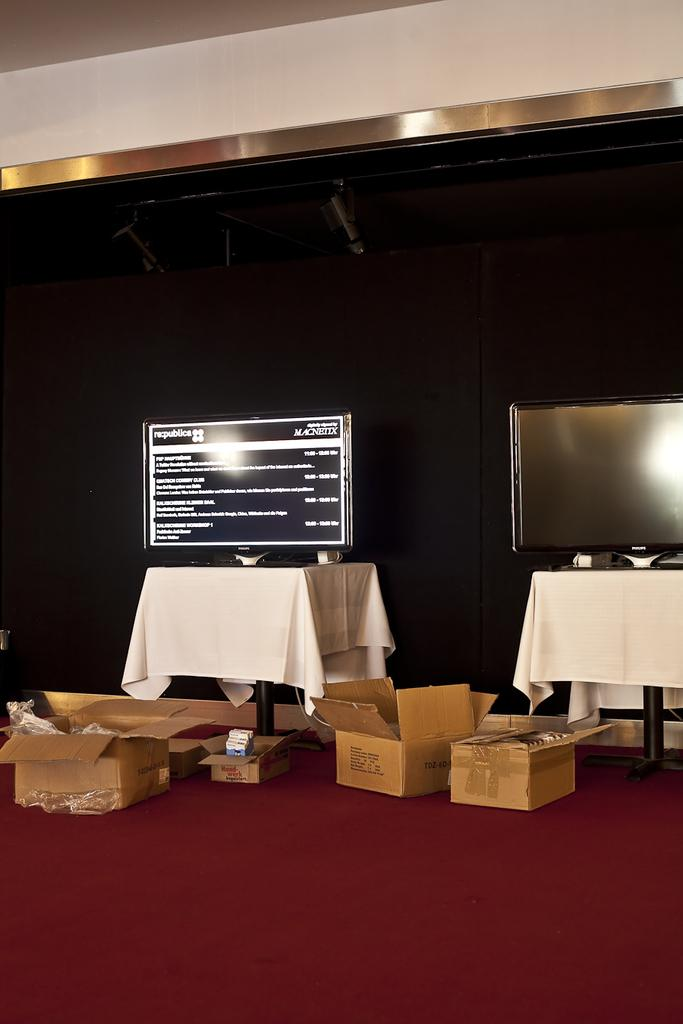What objects are on the floor in the image? There are carton boxes on the floor. What electronic devices are present in the image? There are two televisions on tables. What color is the wall in the background of the image? There is a black wall in the background. What type of thrill can be seen on the iron in the image? There is no iron or thrill present in the image. 